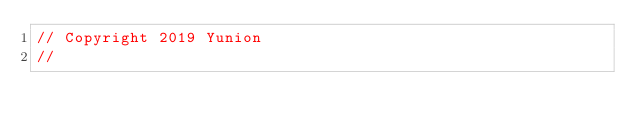Convert code to text. <code><loc_0><loc_0><loc_500><loc_500><_Go_>// Copyright 2019 Yunion
//</code> 